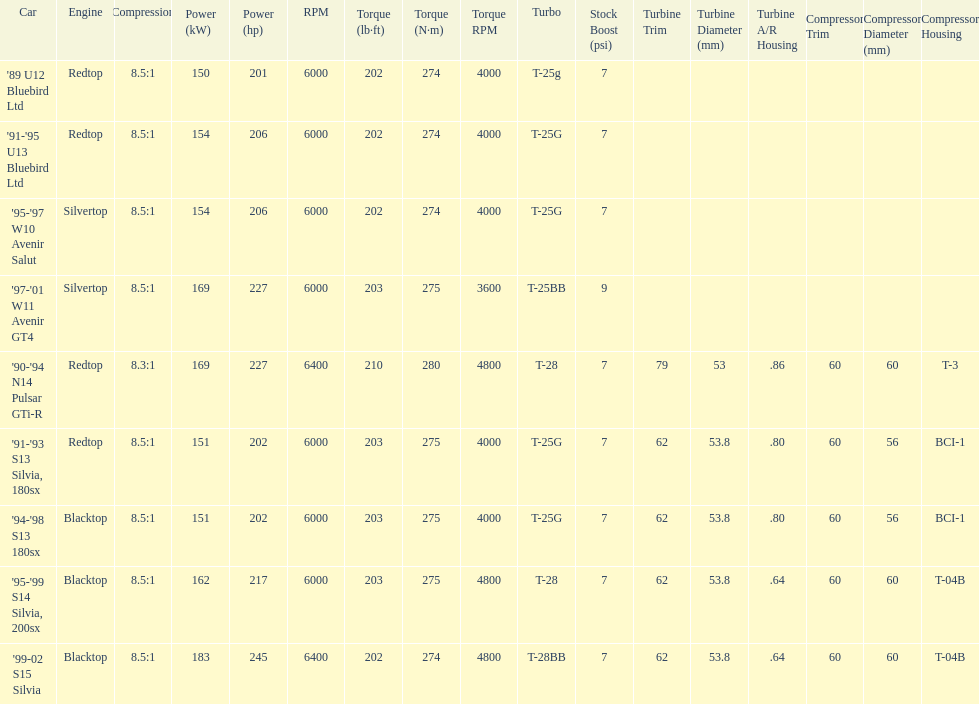Which engines were used after 1999? Silvertop, Blacktop. 